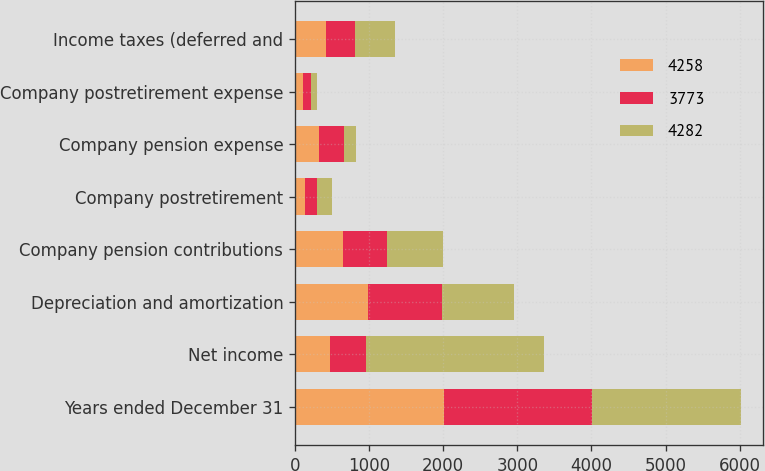Convert chart to OTSL. <chart><loc_0><loc_0><loc_500><loc_500><stacked_bar_chart><ecel><fcel>Years ended December 31<fcel>Net income<fcel>Depreciation and amortization<fcel>Company pension contributions<fcel>Company postretirement<fcel>Company pension expense<fcel>Company postretirement expense<fcel>Income taxes (deferred and<nl><fcel>4258<fcel>2005<fcel>478<fcel>986<fcel>654<fcel>134<fcel>331<fcel>106<fcel>417<nl><fcel>3773<fcel>2004<fcel>478<fcel>999<fcel>591<fcel>168<fcel>325<fcel>110<fcel>396<nl><fcel>4282<fcel>2003<fcel>2403<fcel>964<fcel>749<fcel>194<fcel>168<fcel>88<fcel>539<nl></chart> 